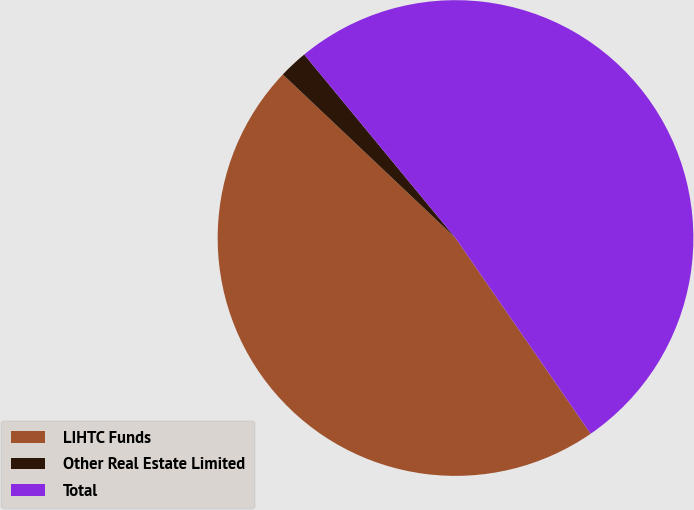Convert chart to OTSL. <chart><loc_0><loc_0><loc_500><loc_500><pie_chart><fcel>LIHTC Funds<fcel>Other Real Estate Limited<fcel>Total<nl><fcel>46.68%<fcel>1.96%<fcel>51.35%<nl></chart> 